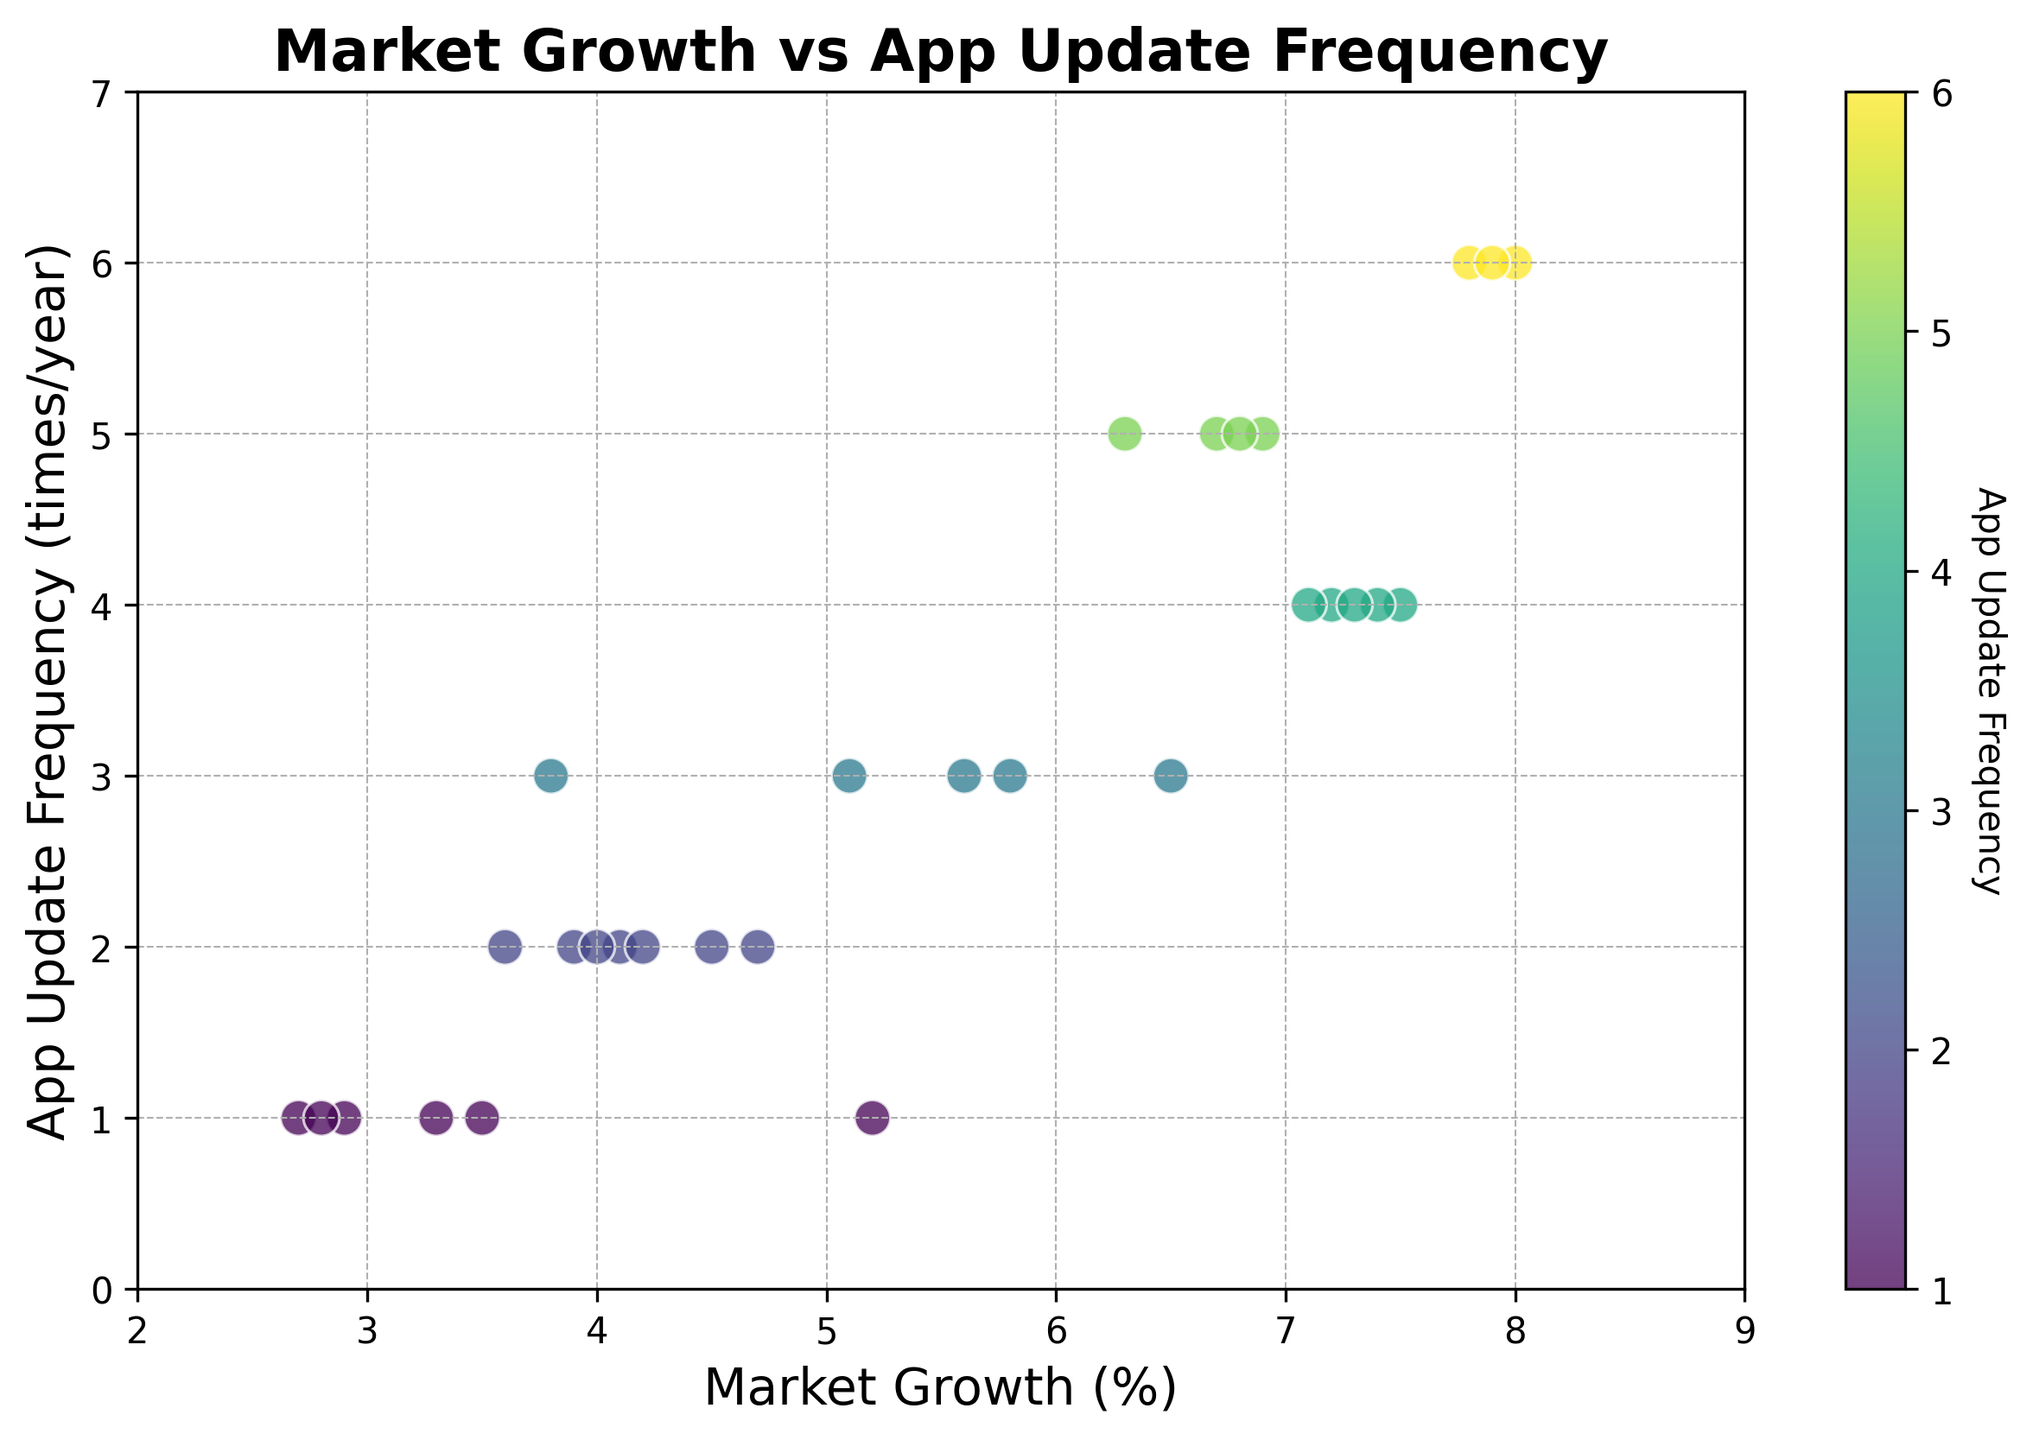How does Market Growth correlate with App Update Frequency? To determine the correlation, visually inspect the scatter plot for any clear pattern. The data points tend to move upwards (increasing App Update Frequency) as Market Growth increases, indicating a positive correlation.
Answer: Positive What's the Market Growth value for the apps updated 6 times a year? Identify the data points along the y-axis at App Update Frequency of 6. The corresponding x-values (Market Growth) for these points are close to 8.0 and 7.9.
Answer: 8.0 and 7.9 What's the highest Market Growth in the figure? Look at the data points spread along the x-axis and find the maximum value. The highest Market Growth value is 8.0.
Answer: 8.0 Are there any data points where Market Growth is below 3%, but App Update Frequency is more than 2 times/year? Examine the leftmost section of the scatter plot (Market Growth < 3%). There are no data points in this region with an App Update Frequency greater than 2 since all points here have frequencies of 1.
Answer: No What is the average App Update Frequency for Market Growth values between 6% and 7%? Identify data points where Market Growth is between 6% and 7%. The App Update Frequencies for these points are 5, 5, 4, and 4. Sum these frequencies (5+5+4+4 = 18) and divide by the number of points (18/4 = 4.5).
Answer: 4.5 For which Market Growth values are there multiple App Update Frequencies? Check for Market Growth values that appear more than once on the x-axis and have different y-values (App Update Frequencies). Market Growth values 3.8, 4.0, 4.1, 4.2, and 4.7 each have more than one frequency.
Answer: 3.8, 4.0, 4.1, 4.2, 4.7 Does increasing the App Update Frequency always result in higher Market Growth? Compare data points sequentially along the y-axis. While higher frequencies often correspond with higher Market Growth, there are exceptions (e.g., Market Growth values around 3%-4% span various update frequencies).
Answer: No How many data points fall within the Market Growth range of 5% to 6%? Count the number of points along the x-axis within the 5% to 6% range. There are 4 data points in this range.
Answer: 4 Which App Update Frequency has the broadest Market Growth range? Examine the scatter plot to see which y-axis value spans the widest x-axis values. App Update Frequency of 3 spans the Market Growth range from approximately 2.8% to 5.8%.
Answer: 3 What is the Market Growth range for apps updated once a year? Identify all the data points on the y-axis at 1 App Update Frequency and note the x-values. These Market Growth values range from approximately 2.7% to 5.2%.
Answer: 2.7% to 5.2% 